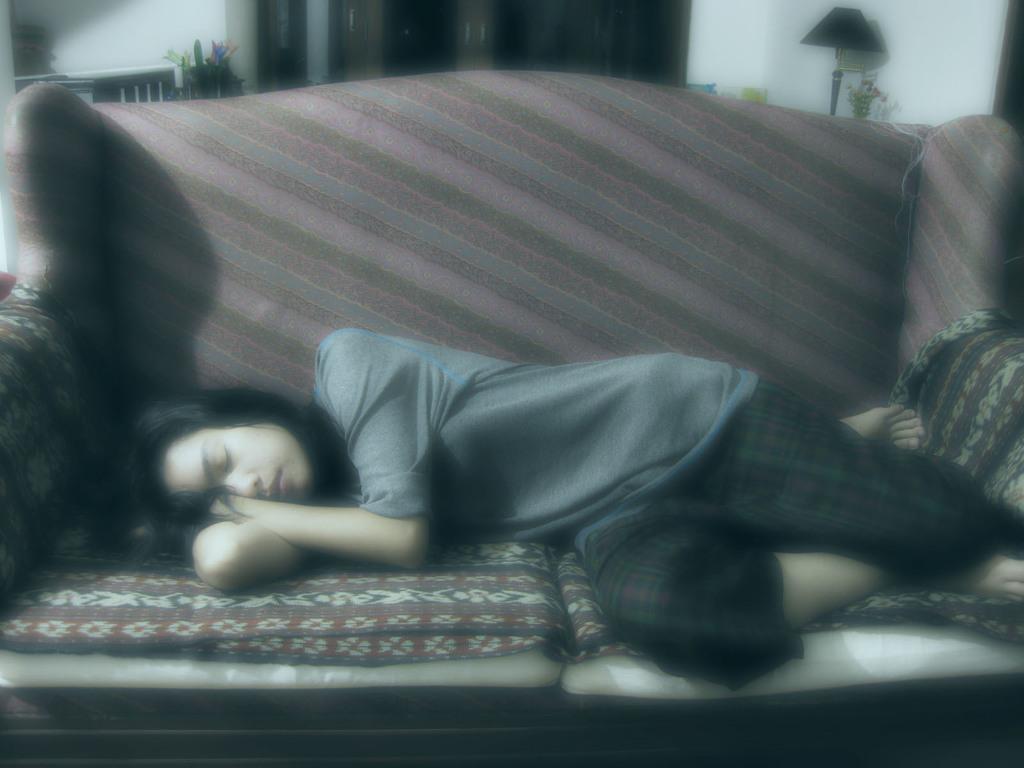How would you summarize this image in a sentence or two? In the picture I can see a woman is lying on the sofa. In the background I can see a light lamp, plants, wall and some other things. This image is little bit blurred. 